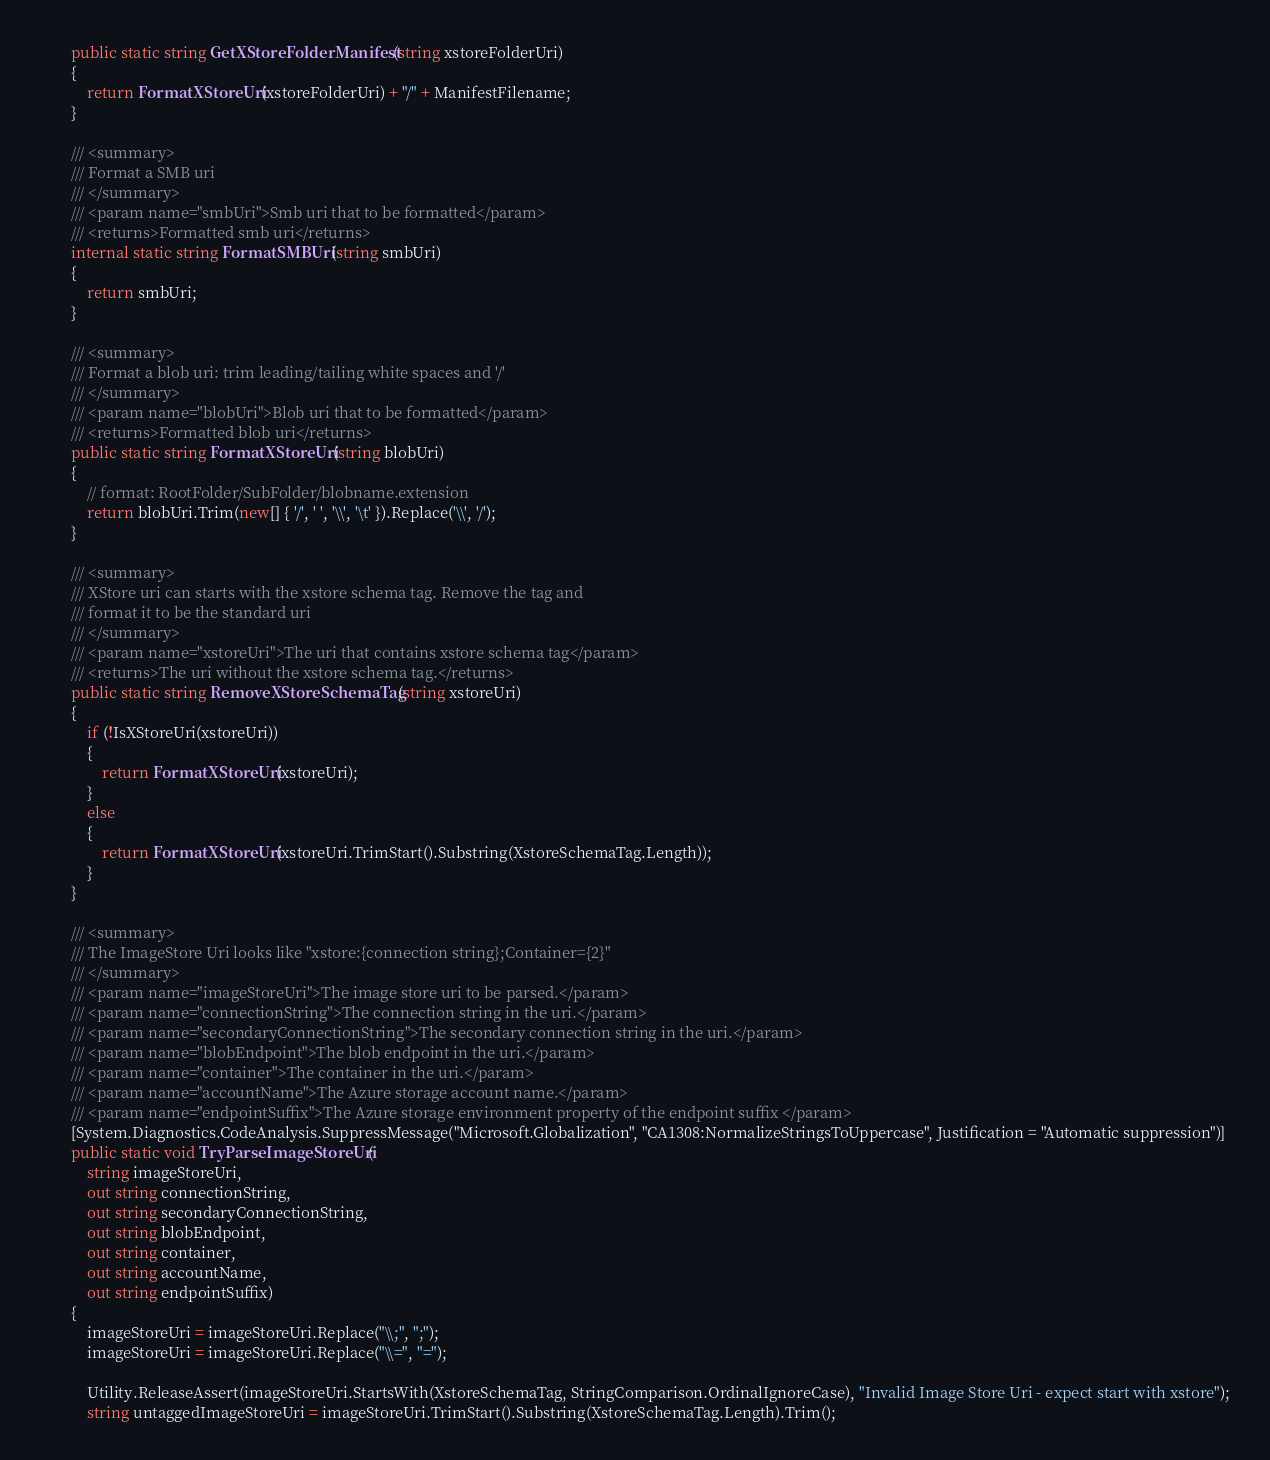Convert code to text. <code><loc_0><loc_0><loc_500><loc_500><_C#_>        public static string GetXStoreFolderManifest(string xstoreFolderUri)
        {
            return FormatXStoreUri(xstoreFolderUri) + "/" + ManifestFilename;
        }

        /// <summary>
        /// Format a SMB uri
        /// </summary>
        /// <param name="smbUri">Smb uri that to be formatted</param>
        /// <returns>Formatted smb uri</returns>
        internal static string FormatSMBUri(string smbUri)
        {
            return smbUri;
        }

        /// <summary>
        /// Format a blob uri: trim leading/tailing white spaces and '/'
        /// </summary>
        /// <param name="blobUri">Blob uri that to be formatted</param>
        /// <returns>Formatted blob uri</returns>
        public static string FormatXStoreUri(string blobUri)
        {
            // format: RootFolder/SubFolder/blobname.extension
            return blobUri.Trim(new[] { '/', ' ', '\\', '\t' }).Replace('\\', '/');
        }

        /// <summary>
        /// XStore uri can starts with the xstore schema tag. Remove the tag and
        /// format it to be the standard uri
        /// </summary>
        /// <param name="xstoreUri">The uri that contains xstore schema tag</param>
        /// <returns>The uri without the xstore schema tag.</returns>
        public static string RemoveXStoreSchemaTag(string xstoreUri)
        {
            if (!IsXStoreUri(xstoreUri))
            {
                return FormatXStoreUri(xstoreUri);
            }
            else
            {
                return FormatXStoreUri(xstoreUri.TrimStart().Substring(XstoreSchemaTag.Length));
            }
        }

        /// <summary>
        /// The ImageStore Uri looks like "xstore:{connection string};Container={2}"
        /// </summary>
        /// <param name="imageStoreUri">The image store uri to be parsed.</param>
        /// <param name="connectionString">The connection string in the uri.</param>
        /// <param name="secondaryConnectionString">The secondary connection string in the uri.</param>
        /// <param name="blobEndpoint">The blob endpoint in the uri.</param>
        /// <param name="container">The container in the uri.</param>
        /// <param name="accountName">The Azure storage account name.</param>
        /// <param name="endpointSuffix">The Azure storage environment property of the endpoint suffix </param>
        [System.Diagnostics.CodeAnalysis.SuppressMessage("Microsoft.Globalization", "CA1308:NormalizeStringsToUppercase", Justification = "Automatic suppression")]
        public static void TryParseImageStoreUri(
            string imageStoreUri,
            out string connectionString,
            out string secondaryConnectionString,
            out string blobEndpoint,
            out string container,
            out string accountName,
            out string endpointSuffix)
        {
            imageStoreUri = imageStoreUri.Replace("\\;", ";");
            imageStoreUri = imageStoreUri.Replace("\\=", "=");

            Utility.ReleaseAssert(imageStoreUri.StartsWith(XstoreSchemaTag, StringComparison.OrdinalIgnoreCase), "Invalid Image Store Uri - expect start with xstore");
            string untaggedImageStoreUri = imageStoreUri.TrimStart().Substring(XstoreSchemaTag.Length).Trim();
</code> 